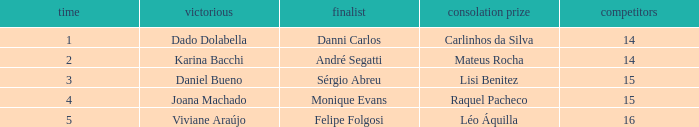Would you be able to parse every entry in this table? {'header': ['time', 'victorious', 'finalist', 'consolation prize', 'competitors'], 'rows': [['1', 'Dado Dolabella', 'Danni Carlos', 'Carlinhos da Silva', '14'], ['2', 'Karina Bacchi', 'André Segatti', 'Mateus Rocha', '14'], ['3', 'Daniel Bueno', 'Sérgio Abreu', 'Lisi Benitez', '15'], ['4', 'Joana Machado', 'Monique Evans', 'Raquel Pacheco', '15'], ['5', 'Viviane Araújo', 'Felipe Folgosi', 'Léo Áquilla', '16']]} In what season was the winner Dado Dolabella? 1.0. 